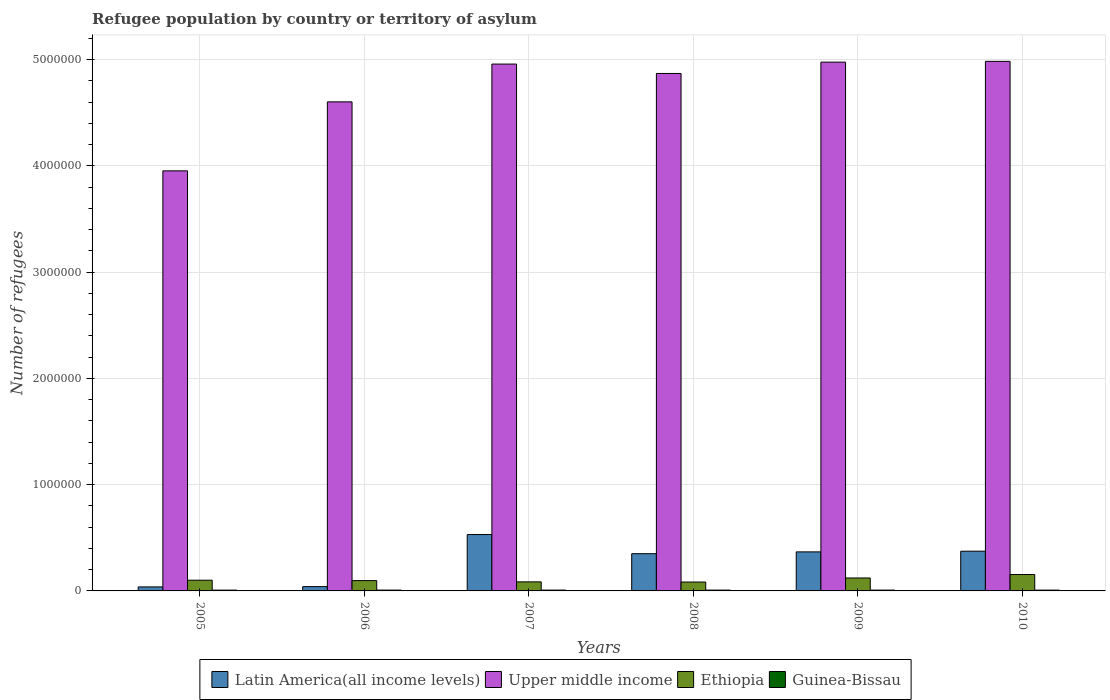How many different coloured bars are there?
Your response must be concise. 4. How many groups of bars are there?
Provide a short and direct response. 6. Are the number of bars per tick equal to the number of legend labels?
Your response must be concise. Yes. How many bars are there on the 3rd tick from the left?
Your answer should be very brief. 4. How many bars are there on the 1st tick from the right?
Keep it short and to the point. 4. What is the label of the 1st group of bars from the left?
Make the answer very short. 2005. In how many cases, is the number of bars for a given year not equal to the number of legend labels?
Keep it short and to the point. 0. What is the number of refugees in Ethiopia in 2010?
Your response must be concise. 1.54e+05. Across all years, what is the maximum number of refugees in Latin America(all income levels)?
Your response must be concise. 5.31e+05. Across all years, what is the minimum number of refugees in Guinea-Bissau?
Ensure brevity in your answer.  7616. In which year was the number of refugees in Ethiopia maximum?
Offer a terse response. 2010. In which year was the number of refugees in Ethiopia minimum?
Offer a very short reply. 2008. What is the total number of refugees in Guinea-Bissau in the graph?
Provide a short and direct response. 4.67e+04. What is the difference between the number of refugees in Latin America(all income levels) in 2008 and that in 2010?
Make the answer very short. -2.36e+04. What is the difference between the number of refugees in Ethiopia in 2009 and the number of refugees in Latin America(all income levels) in 2006?
Keep it short and to the point. 8.13e+04. What is the average number of refugees in Latin America(all income levels) per year?
Make the answer very short. 2.83e+05. In the year 2006, what is the difference between the number of refugees in Upper middle income and number of refugees in Ethiopia?
Ensure brevity in your answer.  4.51e+06. In how many years, is the number of refugees in Guinea-Bissau greater than 4000000?
Your response must be concise. 0. What is the ratio of the number of refugees in Guinea-Bissau in 2008 to that in 2010?
Ensure brevity in your answer.  1.03. Is the difference between the number of refugees in Upper middle income in 2005 and 2006 greater than the difference between the number of refugees in Ethiopia in 2005 and 2006?
Your answer should be very brief. No. What is the difference between the highest and the second highest number of refugees in Ethiopia?
Offer a terse response. 3.24e+04. What is the difference between the highest and the lowest number of refugees in Guinea-Bissau?
Provide a succinct answer. 282. In how many years, is the number of refugees in Ethiopia greater than the average number of refugees in Ethiopia taken over all years?
Offer a very short reply. 2. Is it the case that in every year, the sum of the number of refugees in Latin America(all income levels) and number of refugees in Guinea-Bissau is greater than the sum of number of refugees in Upper middle income and number of refugees in Ethiopia?
Keep it short and to the point. No. What does the 3rd bar from the left in 2006 represents?
Your answer should be compact. Ethiopia. What does the 2nd bar from the right in 2007 represents?
Offer a terse response. Ethiopia. Is it the case that in every year, the sum of the number of refugees in Ethiopia and number of refugees in Upper middle income is greater than the number of refugees in Latin America(all income levels)?
Provide a succinct answer. Yes. Are all the bars in the graph horizontal?
Your response must be concise. No. How many years are there in the graph?
Provide a succinct answer. 6. Are the values on the major ticks of Y-axis written in scientific E-notation?
Your answer should be compact. No. How many legend labels are there?
Make the answer very short. 4. What is the title of the graph?
Provide a succinct answer. Refugee population by country or territory of asylum. What is the label or title of the X-axis?
Offer a very short reply. Years. What is the label or title of the Y-axis?
Offer a very short reply. Number of refugees. What is the Number of refugees of Latin America(all income levels) in 2005?
Offer a terse response. 3.77e+04. What is the Number of refugees in Upper middle income in 2005?
Offer a terse response. 3.95e+06. What is the Number of refugees of Ethiopia in 2005?
Keep it short and to the point. 1.01e+05. What is the Number of refugees of Guinea-Bissau in 2005?
Your response must be concise. 7616. What is the Number of refugees in Latin America(all income levels) in 2006?
Provide a succinct answer. 4.06e+04. What is the Number of refugees in Upper middle income in 2006?
Offer a very short reply. 4.60e+06. What is the Number of refugees in Ethiopia in 2006?
Ensure brevity in your answer.  9.70e+04. What is the Number of refugees of Guinea-Bissau in 2006?
Your answer should be very brief. 7804. What is the Number of refugees in Latin America(all income levels) in 2007?
Make the answer very short. 5.31e+05. What is the Number of refugees of Upper middle income in 2007?
Your response must be concise. 4.96e+06. What is the Number of refugees in Ethiopia in 2007?
Provide a short and direct response. 8.52e+04. What is the Number of refugees of Guinea-Bissau in 2007?
Your answer should be very brief. 7860. What is the Number of refugees in Latin America(all income levels) in 2008?
Your response must be concise. 3.50e+05. What is the Number of refugees of Upper middle income in 2008?
Provide a succinct answer. 4.87e+06. What is the Number of refugees in Ethiopia in 2008?
Keep it short and to the point. 8.36e+04. What is the Number of refugees of Guinea-Bissau in 2008?
Your answer should be compact. 7884. What is the Number of refugees of Latin America(all income levels) in 2009?
Provide a short and direct response. 3.67e+05. What is the Number of refugees of Upper middle income in 2009?
Ensure brevity in your answer.  4.98e+06. What is the Number of refugees of Ethiopia in 2009?
Give a very brief answer. 1.22e+05. What is the Number of refugees of Guinea-Bissau in 2009?
Provide a short and direct response. 7898. What is the Number of refugees of Latin America(all income levels) in 2010?
Give a very brief answer. 3.74e+05. What is the Number of refugees of Upper middle income in 2010?
Your answer should be compact. 4.98e+06. What is the Number of refugees in Ethiopia in 2010?
Offer a very short reply. 1.54e+05. What is the Number of refugees in Guinea-Bissau in 2010?
Your answer should be very brief. 7679. Across all years, what is the maximum Number of refugees of Latin America(all income levels)?
Provide a succinct answer. 5.31e+05. Across all years, what is the maximum Number of refugees in Upper middle income?
Give a very brief answer. 4.98e+06. Across all years, what is the maximum Number of refugees of Ethiopia?
Offer a terse response. 1.54e+05. Across all years, what is the maximum Number of refugees in Guinea-Bissau?
Your answer should be compact. 7898. Across all years, what is the minimum Number of refugees in Latin America(all income levels)?
Ensure brevity in your answer.  3.77e+04. Across all years, what is the minimum Number of refugees in Upper middle income?
Offer a terse response. 3.95e+06. Across all years, what is the minimum Number of refugees in Ethiopia?
Provide a succinct answer. 8.36e+04. Across all years, what is the minimum Number of refugees of Guinea-Bissau?
Make the answer very short. 7616. What is the total Number of refugees of Latin America(all income levels) in the graph?
Ensure brevity in your answer.  1.70e+06. What is the total Number of refugees of Upper middle income in the graph?
Offer a terse response. 2.83e+07. What is the total Number of refugees in Ethiopia in the graph?
Provide a short and direct response. 6.43e+05. What is the total Number of refugees of Guinea-Bissau in the graph?
Your answer should be compact. 4.67e+04. What is the difference between the Number of refugees of Latin America(all income levels) in 2005 and that in 2006?
Keep it short and to the point. -2828. What is the difference between the Number of refugees of Upper middle income in 2005 and that in 2006?
Your response must be concise. -6.49e+05. What is the difference between the Number of refugees in Ethiopia in 2005 and that in 2006?
Your response must be concise. 3837. What is the difference between the Number of refugees in Guinea-Bissau in 2005 and that in 2006?
Your answer should be very brief. -188. What is the difference between the Number of refugees in Latin America(all income levels) in 2005 and that in 2007?
Give a very brief answer. -4.93e+05. What is the difference between the Number of refugees in Upper middle income in 2005 and that in 2007?
Your response must be concise. -1.00e+06. What is the difference between the Number of refugees in Ethiopia in 2005 and that in 2007?
Ensure brevity in your answer.  1.56e+04. What is the difference between the Number of refugees of Guinea-Bissau in 2005 and that in 2007?
Offer a very short reply. -244. What is the difference between the Number of refugees of Latin America(all income levels) in 2005 and that in 2008?
Your response must be concise. -3.13e+05. What is the difference between the Number of refugees of Upper middle income in 2005 and that in 2008?
Keep it short and to the point. -9.16e+05. What is the difference between the Number of refugees in Ethiopia in 2005 and that in 2008?
Offer a very short reply. 1.72e+04. What is the difference between the Number of refugees of Guinea-Bissau in 2005 and that in 2008?
Offer a very short reply. -268. What is the difference between the Number of refugees in Latin America(all income levels) in 2005 and that in 2009?
Offer a terse response. -3.30e+05. What is the difference between the Number of refugees of Upper middle income in 2005 and that in 2009?
Your answer should be very brief. -1.02e+06. What is the difference between the Number of refugees of Ethiopia in 2005 and that in 2009?
Keep it short and to the point. -2.11e+04. What is the difference between the Number of refugees in Guinea-Bissau in 2005 and that in 2009?
Your answer should be very brief. -282. What is the difference between the Number of refugees in Latin America(all income levels) in 2005 and that in 2010?
Your answer should be very brief. -3.36e+05. What is the difference between the Number of refugees of Upper middle income in 2005 and that in 2010?
Provide a succinct answer. -1.03e+06. What is the difference between the Number of refugees in Ethiopia in 2005 and that in 2010?
Provide a short and direct response. -5.35e+04. What is the difference between the Number of refugees in Guinea-Bissau in 2005 and that in 2010?
Provide a short and direct response. -63. What is the difference between the Number of refugees of Latin America(all income levels) in 2006 and that in 2007?
Ensure brevity in your answer.  -4.90e+05. What is the difference between the Number of refugees in Upper middle income in 2006 and that in 2007?
Provide a succinct answer. -3.55e+05. What is the difference between the Number of refugees of Ethiopia in 2006 and that in 2007?
Provide a succinct answer. 1.18e+04. What is the difference between the Number of refugees in Guinea-Bissau in 2006 and that in 2007?
Ensure brevity in your answer.  -56. What is the difference between the Number of refugees in Latin America(all income levels) in 2006 and that in 2008?
Provide a succinct answer. -3.10e+05. What is the difference between the Number of refugees of Upper middle income in 2006 and that in 2008?
Your answer should be compact. -2.67e+05. What is the difference between the Number of refugees of Ethiopia in 2006 and that in 2008?
Your response must be concise. 1.34e+04. What is the difference between the Number of refugees of Guinea-Bissau in 2006 and that in 2008?
Make the answer very short. -80. What is the difference between the Number of refugees in Latin America(all income levels) in 2006 and that in 2009?
Provide a succinct answer. -3.27e+05. What is the difference between the Number of refugees in Upper middle income in 2006 and that in 2009?
Provide a succinct answer. -3.74e+05. What is the difference between the Number of refugees in Ethiopia in 2006 and that in 2009?
Offer a terse response. -2.49e+04. What is the difference between the Number of refugees in Guinea-Bissau in 2006 and that in 2009?
Keep it short and to the point. -94. What is the difference between the Number of refugees in Latin America(all income levels) in 2006 and that in 2010?
Keep it short and to the point. -3.33e+05. What is the difference between the Number of refugees in Upper middle income in 2006 and that in 2010?
Keep it short and to the point. -3.81e+05. What is the difference between the Number of refugees in Ethiopia in 2006 and that in 2010?
Your answer should be compact. -5.73e+04. What is the difference between the Number of refugees in Guinea-Bissau in 2006 and that in 2010?
Make the answer very short. 125. What is the difference between the Number of refugees of Latin America(all income levels) in 2007 and that in 2008?
Make the answer very short. 1.80e+05. What is the difference between the Number of refugees of Upper middle income in 2007 and that in 2008?
Keep it short and to the point. 8.84e+04. What is the difference between the Number of refugees of Ethiopia in 2007 and that in 2008?
Provide a succinct answer. 1600. What is the difference between the Number of refugees in Latin America(all income levels) in 2007 and that in 2009?
Your answer should be very brief. 1.63e+05. What is the difference between the Number of refugees in Upper middle income in 2007 and that in 2009?
Your response must be concise. -1.83e+04. What is the difference between the Number of refugees of Ethiopia in 2007 and that in 2009?
Provide a short and direct response. -3.67e+04. What is the difference between the Number of refugees in Guinea-Bissau in 2007 and that in 2009?
Give a very brief answer. -38. What is the difference between the Number of refugees in Latin America(all income levels) in 2007 and that in 2010?
Offer a terse response. 1.57e+05. What is the difference between the Number of refugees in Upper middle income in 2007 and that in 2010?
Make the answer very short. -2.56e+04. What is the difference between the Number of refugees of Ethiopia in 2007 and that in 2010?
Make the answer very short. -6.91e+04. What is the difference between the Number of refugees in Guinea-Bissau in 2007 and that in 2010?
Keep it short and to the point. 181. What is the difference between the Number of refugees of Latin America(all income levels) in 2008 and that in 2009?
Your response must be concise. -1.72e+04. What is the difference between the Number of refugees in Upper middle income in 2008 and that in 2009?
Offer a very short reply. -1.07e+05. What is the difference between the Number of refugees of Ethiopia in 2008 and that in 2009?
Provide a short and direct response. -3.83e+04. What is the difference between the Number of refugees in Guinea-Bissau in 2008 and that in 2009?
Ensure brevity in your answer.  -14. What is the difference between the Number of refugees in Latin America(all income levels) in 2008 and that in 2010?
Offer a very short reply. -2.36e+04. What is the difference between the Number of refugees of Upper middle income in 2008 and that in 2010?
Your response must be concise. -1.14e+05. What is the difference between the Number of refugees in Ethiopia in 2008 and that in 2010?
Give a very brief answer. -7.07e+04. What is the difference between the Number of refugees of Guinea-Bissau in 2008 and that in 2010?
Offer a terse response. 205. What is the difference between the Number of refugees of Latin America(all income levels) in 2009 and that in 2010?
Provide a succinct answer. -6428. What is the difference between the Number of refugees in Upper middle income in 2009 and that in 2010?
Offer a terse response. -7314. What is the difference between the Number of refugees in Ethiopia in 2009 and that in 2010?
Your response must be concise. -3.24e+04. What is the difference between the Number of refugees of Guinea-Bissau in 2009 and that in 2010?
Provide a short and direct response. 219. What is the difference between the Number of refugees of Latin America(all income levels) in 2005 and the Number of refugees of Upper middle income in 2006?
Provide a succinct answer. -4.56e+06. What is the difference between the Number of refugees in Latin America(all income levels) in 2005 and the Number of refugees in Ethiopia in 2006?
Give a very brief answer. -5.92e+04. What is the difference between the Number of refugees in Latin America(all income levels) in 2005 and the Number of refugees in Guinea-Bissau in 2006?
Give a very brief answer. 2.99e+04. What is the difference between the Number of refugees of Upper middle income in 2005 and the Number of refugees of Ethiopia in 2006?
Make the answer very short. 3.86e+06. What is the difference between the Number of refugees of Upper middle income in 2005 and the Number of refugees of Guinea-Bissau in 2006?
Ensure brevity in your answer.  3.95e+06. What is the difference between the Number of refugees in Ethiopia in 2005 and the Number of refugees in Guinea-Bissau in 2006?
Provide a succinct answer. 9.30e+04. What is the difference between the Number of refugees in Latin America(all income levels) in 2005 and the Number of refugees in Upper middle income in 2007?
Offer a very short reply. -4.92e+06. What is the difference between the Number of refugees in Latin America(all income levels) in 2005 and the Number of refugees in Ethiopia in 2007?
Your response must be concise. -4.74e+04. What is the difference between the Number of refugees of Latin America(all income levels) in 2005 and the Number of refugees of Guinea-Bissau in 2007?
Your answer should be compact. 2.99e+04. What is the difference between the Number of refugees of Upper middle income in 2005 and the Number of refugees of Ethiopia in 2007?
Offer a very short reply. 3.87e+06. What is the difference between the Number of refugees in Upper middle income in 2005 and the Number of refugees in Guinea-Bissau in 2007?
Provide a succinct answer. 3.95e+06. What is the difference between the Number of refugees in Ethiopia in 2005 and the Number of refugees in Guinea-Bissau in 2007?
Make the answer very short. 9.30e+04. What is the difference between the Number of refugees in Latin America(all income levels) in 2005 and the Number of refugees in Upper middle income in 2008?
Ensure brevity in your answer.  -4.83e+06. What is the difference between the Number of refugees of Latin America(all income levels) in 2005 and the Number of refugees of Ethiopia in 2008?
Offer a terse response. -4.58e+04. What is the difference between the Number of refugees in Latin America(all income levels) in 2005 and the Number of refugees in Guinea-Bissau in 2008?
Provide a succinct answer. 2.99e+04. What is the difference between the Number of refugees in Upper middle income in 2005 and the Number of refugees in Ethiopia in 2008?
Provide a succinct answer. 3.87e+06. What is the difference between the Number of refugees of Upper middle income in 2005 and the Number of refugees of Guinea-Bissau in 2008?
Your response must be concise. 3.95e+06. What is the difference between the Number of refugees in Ethiopia in 2005 and the Number of refugees in Guinea-Bissau in 2008?
Give a very brief answer. 9.29e+04. What is the difference between the Number of refugees in Latin America(all income levels) in 2005 and the Number of refugees in Upper middle income in 2009?
Provide a succinct answer. -4.94e+06. What is the difference between the Number of refugees of Latin America(all income levels) in 2005 and the Number of refugees of Ethiopia in 2009?
Provide a short and direct response. -8.41e+04. What is the difference between the Number of refugees in Latin America(all income levels) in 2005 and the Number of refugees in Guinea-Bissau in 2009?
Provide a short and direct response. 2.99e+04. What is the difference between the Number of refugees in Upper middle income in 2005 and the Number of refugees in Ethiopia in 2009?
Provide a short and direct response. 3.83e+06. What is the difference between the Number of refugees of Upper middle income in 2005 and the Number of refugees of Guinea-Bissau in 2009?
Offer a very short reply. 3.95e+06. What is the difference between the Number of refugees in Ethiopia in 2005 and the Number of refugees in Guinea-Bissau in 2009?
Provide a succinct answer. 9.29e+04. What is the difference between the Number of refugees of Latin America(all income levels) in 2005 and the Number of refugees of Upper middle income in 2010?
Give a very brief answer. -4.95e+06. What is the difference between the Number of refugees of Latin America(all income levels) in 2005 and the Number of refugees of Ethiopia in 2010?
Offer a terse response. -1.17e+05. What is the difference between the Number of refugees of Latin America(all income levels) in 2005 and the Number of refugees of Guinea-Bissau in 2010?
Provide a short and direct response. 3.01e+04. What is the difference between the Number of refugees of Upper middle income in 2005 and the Number of refugees of Ethiopia in 2010?
Keep it short and to the point. 3.80e+06. What is the difference between the Number of refugees of Upper middle income in 2005 and the Number of refugees of Guinea-Bissau in 2010?
Provide a short and direct response. 3.95e+06. What is the difference between the Number of refugees in Ethiopia in 2005 and the Number of refugees in Guinea-Bissau in 2010?
Keep it short and to the point. 9.31e+04. What is the difference between the Number of refugees of Latin America(all income levels) in 2006 and the Number of refugees of Upper middle income in 2007?
Give a very brief answer. -4.92e+06. What is the difference between the Number of refugees of Latin America(all income levels) in 2006 and the Number of refugees of Ethiopia in 2007?
Offer a very short reply. -4.46e+04. What is the difference between the Number of refugees of Latin America(all income levels) in 2006 and the Number of refugees of Guinea-Bissau in 2007?
Your answer should be very brief. 3.27e+04. What is the difference between the Number of refugees in Upper middle income in 2006 and the Number of refugees in Ethiopia in 2007?
Provide a short and direct response. 4.52e+06. What is the difference between the Number of refugees in Upper middle income in 2006 and the Number of refugees in Guinea-Bissau in 2007?
Your response must be concise. 4.59e+06. What is the difference between the Number of refugees of Ethiopia in 2006 and the Number of refugees of Guinea-Bissau in 2007?
Your answer should be compact. 8.91e+04. What is the difference between the Number of refugees in Latin America(all income levels) in 2006 and the Number of refugees in Upper middle income in 2008?
Offer a very short reply. -4.83e+06. What is the difference between the Number of refugees of Latin America(all income levels) in 2006 and the Number of refugees of Ethiopia in 2008?
Provide a succinct answer. -4.30e+04. What is the difference between the Number of refugees of Latin America(all income levels) in 2006 and the Number of refugees of Guinea-Bissau in 2008?
Provide a succinct answer. 3.27e+04. What is the difference between the Number of refugees of Upper middle income in 2006 and the Number of refugees of Ethiopia in 2008?
Give a very brief answer. 4.52e+06. What is the difference between the Number of refugees in Upper middle income in 2006 and the Number of refugees in Guinea-Bissau in 2008?
Your answer should be compact. 4.59e+06. What is the difference between the Number of refugees of Ethiopia in 2006 and the Number of refugees of Guinea-Bissau in 2008?
Offer a terse response. 8.91e+04. What is the difference between the Number of refugees of Latin America(all income levels) in 2006 and the Number of refugees of Upper middle income in 2009?
Keep it short and to the point. -4.94e+06. What is the difference between the Number of refugees in Latin America(all income levels) in 2006 and the Number of refugees in Ethiopia in 2009?
Offer a very short reply. -8.13e+04. What is the difference between the Number of refugees of Latin America(all income levels) in 2006 and the Number of refugees of Guinea-Bissau in 2009?
Provide a short and direct response. 3.27e+04. What is the difference between the Number of refugees in Upper middle income in 2006 and the Number of refugees in Ethiopia in 2009?
Offer a terse response. 4.48e+06. What is the difference between the Number of refugees in Upper middle income in 2006 and the Number of refugees in Guinea-Bissau in 2009?
Offer a very short reply. 4.59e+06. What is the difference between the Number of refugees of Ethiopia in 2006 and the Number of refugees of Guinea-Bissau in 2009?
Provide a short and direct response. 8.91e+04. What is the difference between the Number of refugees of Latin America(all income levels) in 2006 and the Number of refugees of Upper middle income in 2010?
Offer a very short reply. -4.94e+06. What is the difference between the Number of refugees of Latin America(all income levels) in 2006 and the Number of refugees of Ethiopia in 2010?
Your answer should be compact. -1.14e+05. What is the difference between the Number of refugees in Latin America(all income levels) in 2006 and the Number of refugees in Guinea-Bissau in 2010?
Give a very brief answer. 3.29e+04. What is the difference between the Number of refugees of Upper middle income in 2006 and the Number of refugees of Ethiopia in 2010?
Make the answer very short. 4.45e+06. What is the difference between the Number of refugees of Upper middle income in 2006 and the Number of refugees of Guinea-Bissau in 2010?
Give a very brief answer. 4.59e+06. What is the difference between the Number of refugees of Ethiopia in 2006 and the Number of refugees of Guinea-Bissau in 2010?
Provide a succinct answer. 8.93e+04. What is the difference between the Number of refugees of Latin America(all income levels) in 2007 and the Number of refugees of Upper middle income in 2008?
Give a very brief answer. -4.34e+06. What is the difference between the Number of refugees in Latin America(all income levels) in 2007 and the Number of refugees in Ethiopia in 2008?
Give a very brief answer. 4.47e+05. What is the difference between the Number of refugees in Latin America(all income levels) in 2007 and the Number of refugees in Guinea-Bissau in 2008?
Provide a succinct answer. 5.23e+05. What is the difference between the Number of refugees in Upper middle income in 2007 and the Number of refugees in Ethiopia in 2008?
Your answer should be very brief. 4.87e+06. What is the difference between the Number of refugees in Upper middle income in 2007 and the Number of refugees in Guinea-Bissau in 2008?
Your answer should be compact. 4.95e+06. What is the difference between the Number of refugees in Ethiopia in 2007 and the Number of refugees in Guinea-Bissau in 2008?
Offer a terse response. 7.73e+04. What is the difference between the Number of refugees in Latin America(all income levels) in 2007 and the Number of refugees in Upper middle income in 2009?
Offer a terse response. -4.45e+06. What is the difference between the Number of refugees in Latin America(all income levels) in 2007 and the Number of refugees in Ethiopia in 2009?
Give a very brief answer. 4.09e+05. What is the difference between the Number of refugees of Latin America(all income levels) in 2007 and the Number of refugees of Guinea-Bissau in 2009?
Provide a short and direct response. 5.23e+05. What is the difference between the Number of refugees in Upper middle income in 2007 and the Number of refugees in Ethiopia in 2009?
Offer a terse response. 4.84e+06. What is the difference between the Number of refugees of Upper middle income in 2007 and the Number of refugees of Guinea-Bissau in 2009?
Your answer should be very brief. 4.95e+06. What is the difference between the Number of refugees in Ethiopia in 2007 and the Number of refugees in Guinea-Bissau in 2009?
Make the answer very short. 7.73e+04. What is the difference between the Number of refugees in Latin America(all income levels) in 2007 and the Number of refugees in Upper middle income in 2010?
Keep it short and to the point. -4.45e+06. What is the difference between the Number of refugees in Latin America(all income levels) in 2007 and the Number of refugees in Ethiopia in 2010?
Keep it short and to the point. 3.76e+05. What is the difference between the Number of refugees of Latin America(all income levels) in 2007 and the Number of refugees of Guinea-Bissau in 2010?
Make the answer very short. 5.23e+05. What is the difference between the Number of refugees of Upper middle income in 2007 and the Number of refugees of Ethiopia in 2010?
Ensure brevity in your answer.  4.80e+06. What is the difference between the Number of refugees of Upper middle income in 2007 and the Number of refugees of Guinea-Bissau in 2010?
Offer a terse response. 4.95e+06. What is the difference between the Number of refugees of Ethiopia in 2007 and the Number of refugees of Guinea-Bissau in 2010?
Keep it short and to the point. 7.75e+04. What is the difference between the Number of refugees in Latin America(all income levels) in 2008 and the Number of refugees in Upper middle income in 2009?
Offer a very short reply. -4.63e+06. What is the difference between the Number of refugees of Latin America(all income levels) in 2008 and the Number of refugees of Ethiopia in 2009?
Provide a succinct answer. 2.28e+05. What is the difference between the Number of refugees in Latin America(all income levels) in 2008 and the Number of refugees in Guinea-Bissau in 2009?
Provide a short and direct response. 3.42e+05. What is the difference between the Number of refugees in Upper middle income in 2008 and the Number of refugees in Ethiopia in 2009?
Provide a succinct answer. 4.75e+06. What is the difference between the Number of refugees in Upper middle income in 2008 and the Number of refugees in Guinea-Bissau in 2009?
Your answer should be very brief. 4.86e+06. What is the difference between the Number of refugees in Ethiopia in 2008 and the Number of refugees in Guinea-Bissau in 2009?
Provide a short and direct response. 7.57e+04. What is the difference between the Number of refugees of Latin America(all income levels) in 2008 and the Number of refugees of Upper middle income in 2010?
Your answer should be compact. -4.63e+06. What is the difference between the Number of refugees of Latin America(all income levels) in 2008 and the Number of refugees of Ethiopia in 2010?
Ensure brevity in your answer.  1.96e+05. What is the difference between the Number of refugees in Latin America(all income levels) in 2008 and the Number of refugees in Guinea-Bissau in 2010?
Make the answer very short. 3.43e+05. What is the difference between the Number of refugees of Upper middle income in 2008 and the Number of refugees of Ethiopia in 2010?
Provide a succinct answer. 4.72e+06. What is the difference between the Number of refugees in Upper middle income in 2008 and the Number of refugees in Guinea-Bissau in 2010?
Your answer should be compact. 4.86e+06. What is the difference between the Number of refugees in Ethiopia in 2008 and the Number of refugees in Guinea-Bissau in 2010?
Your answer should be compact. 7.59e+04. What is the difference between the Number of refugees of Latin America(all income levels) in 2009 and the Number of refugees of Upper middle income in 2010?
Offer a very short reply. -4.62e+06. What is the difference between the Number of refugees of Latin America(all income levels) in 2009 and the Number of refugees of Ethiopia in 2010?
Make the answer very short. 2.13e+05. What is the difference between the Number of refugees of Latin America(all income levels) in 2009 and the Number of refugees of Guinea-Bissau in 2010?
Your answer should be compact. 3.60e+05. What is the difference between the Number of refugees of Upper middle income in 2009 and the Number of refugees of Ethiopia in 2010?
Provide a short and direct response. 4.82e+06. What is the difference between the Number of refugees of Upper middle income in 2009 and the Number of refugees of Guinea-Bissau in 2010?
Provide a succinct answer. 4.97e+06. What is the difference between the Number of refugees in Ethiopia in 2009 and the Number of refugees in Guinea-Bissau in 2010?
Keep it short and to the point. 1.14e+05. What is the average Number of refugees of Latin America(all income levels) per year?
Ensure brevity in your answer.  2.83e+05. What is the average Number of refugees of Upper middle income per year?
Make the answer very short. 4.72e+06. What is the average Number of refugees of Ethiopia per year?
Your response must be concise. 1.07e+05. What is the average Number of refugees in Guinea-Bissau per year?
Keep it short and to the point. 7790.17. In the year 2005, what is the difference between the Number of refugees in Latin America(all income levels) and Number of refugees in Upper middle income?
Provide a succinct answer. -3.92e+06. In the year 2005, what is the difference between the Number of refugees of Latin America(all income levels) and Number of refugees of Ethiopia?
Give a very brief answer. -6.31e+04. In the year 2005, what is the difference between the Number of refugees of Latin America(all income levels) and Number of refugees of Guinea-Bissau?
Your response must be concise. 3.01e+04. In the year 2005, what is the difference between the Number of refugees of Upper middle income and Number of refugees of Ethiopia?
Your answer should be very brief. 3.85e+06. In the year 2005, what is the difference between the Number of refugees of Upper middle income and Number of refugees of Guinea-Bissau?
Provide a succinct answer. 3.95e+06. In the year 2005, what is the difference between the Number of refugees in Ethiopia and Number of refugees in Guinea-Bissau?
Offer a terse response. 9.32e+04. In the year 2006, what is the difference between the Number of refugees of Latin America(all income levels) and Number of refugees of Upper middle income?
Keep it short and to the point. -4.56e+06. In the year 2006, what is the difference between the Number of refugees of Latin America(all income levels) and Number of refugees of Ethiopia?
Your response must be concise. -5.64e+04. In the year 2006, what is the difference between the Number of refugees of Latin America(all income levels) and Number of refugees of Guinea-Bissau?
Offer a very short reply. 3.28e+04. In the year 2006, what is the difference between the Number of refugees in Upper middle income and Number of refugees in Ethiopia?
Offer a terse response. 4.51e+06. In the year 2006, what is the difference between the Number of refugees of Upper middle income and Number of refugees of Guinea-Bissau?
Your answer should be compact. 4.59e+06. In the year 2006, what is the difference between the Number of refugees in Ethiopia and Number of refugees in Guinea-Bissau?
Your response must be concise. 8.92e+04. In the year 2007, what is the difference between the Number of refugees in Latin America(all income levels) and Number of refugees in Upper middle income?
Offer a very short reply. -4.43e+06. In the year 2007, what is the difference between the Number of refugees of Latin America(all income levels) and Number of refugees of Ethiopia?
Offer a terse response. 4.45e+05. In the year 2007, what is the difference between the Number of refugees in Latin America(all income levels) and Number of refugees in Guinea-Bissau?
Offer a terse response. 5.23e+05. In the year 2007, what is the difference between the Number of refugees of Upper middle income and Number of refugees of Ethiopia?
Make the answer very short. 4.87e+06. In the year 2007, what is the difference between the Number of refugees in Upper middle income and Number of refugees in Guinea-Bissau?
Provide a short and direct response. 4.95e+06. In the year 2007, what is the difference between the Number of refugees in Ethiopia and Number of refugees in Guinea-Bissau?
Provide a short and direct response. 7.73e+04. In the year 2008, what is the difference between the Number of refugees of Latin America(all income levels) and Number of refugees of Upper middle income?
Your response must be concise. -4.52e+06. In the year 2008, what is the difference between the Number of refugees in Latin America(all income levels) and Number of refugees in Ethiopia?
Provide a succinct answer. 2.67e+05. In the year 2008, what is the difference between the Number of refugees in Latin America(all income levels) and Number of refugees in Guinea-Bissau?
Keep it short and to the point. 3.42e+05. In the year 2008, what is the difference between the Number of refugees in Upper middle income and Number of refugees in Ethiopia?
Your answer should be very brief. 4.79e+06. In the year 2008, what is the difference between the Number of refugees of Upper middle income and Number of refugees of Guinea-Bissau?
Your response must be concise. 4.86e+06. In the year 2008, what is the difference between the Number of refugees in Ethiopia and Number of refugees in Guinea-Bissau?
Provide a succinct answer. 7.57e+04. In the year 2009, what is the difference between the Number of refugees in Latin America(all income levels) and Number of refugees in Upper middle income?
Ensure brevity in your answer.  -4.61e+06. In the year 2009, what is the difference between the Number of refugees in Latin America(all income levels) and Number of refugees in Ethiopia?
Provide a short and direct response. 2.46e+05. In the year 2009, what is the difference between the Number of refugees of Latin America(all income levels) and Number of refugees of Guinea-Bissau?
Provide a succinct answer. 3.60e+05. In the year 2009, what is the difference between the Number of refugees of Upper middle income and Number of refugees of Ethiopia?
Your response must be concise. 4.85e+06. In the year 2009, what is the difference between the Number of refugees in Upper middle income and Number of refugees in Guinea-Bissau?
Give a very brief answer. 4.97e+06. In the year 2009, what is the difference between the Number of refugees in Ethiopia and Number of refugees in Guinea-Bissau?
Give a very brief answer. 1.14e+05. In the year 2010, what is the difference between the Number of refugees of Latin America(all income levels) and Number of refugees of Upper middle income?
Give a very brief answer. -4.61e+06. In the year 2010, what is the difference between the Number of refugees in Latin America(all income levels) and Number of refugees in Ethiopia?
Offer a very short reply. 2.20e+05. In the year 2010, what is the difference between the Number of refugees of Latin America(all income levels) and Number of refugees of Guinea-Bissau?
Your answer should be compact. 3.66e+05. In the year 2010, what is the difference between the Number of refugees in Upper middle income and Number of refugees in Ethiopia?
Make the answer very short. 4.83e+06. In the year 2010, what is the difference between the Number of refugees in Upper middle income and Number of refugees in Guinea-Bissau?
Keep it short and to the point. 4.98e+06. In the year 2010, what is the difference between the Number of refugees in Ethiopia and Number of refugees in Guinea-Bissau?
Your response must be concise. 1.47e+05. What is the ratio of the Number of refugees in Latin America(all income levels) in 2005 to that in 2006?
Your answer should be compact. 0.93. What is the ratio of the Number of refugees of Upper middle income in 2005 to that in 2006?
Offer a very short reply. 0.86. What is the ratio of the Number of refugees of Ethiopia in 2005 to that in 2006?
Offer a terse response. 1.04. What is the ratio of the Number of refugees in Guinea-Bissau in 2005 to that in 2006?
Provide a short and direct response. 0.98. What is the ratio of the Number of refugees of Latin America(all income levels) in 2005 to that in 2007?
Your answer should be very brief. 0.07. What is the ratio of the Number of refugees of Upper middle income in 2005 to that in 2007?
Your answer should be compact. 0.8. What is the ratio of the Number of refugees in Ethiopia in 2005 to that in 2007?
Provide a short and direct response. 1.18. What is the ratio of the Number of refugees of Guinea-Bissau in 2005 to that in 2007?
Offer a very short reply. 0.97. What is the ratio of the Number of refugees in Latin America(all income levels) in 2005 to that in 2008?
Keep it short and to the point. 0.11. What is the ratio of the Number of refugees of Upper middle income in 2005 to that in 2008?
Provide a short and direct response. 0.81. What is the ratio of the Number of refugees in Ethiopia in 2005 to that in 2008?
Keep it short and to the point. 1.21. What is the ratio of the Number of refugees of Latin America(all income levels) in 2005 to that in 2009?
Offer a terse response. 0.1. What is the ratio of the Number of refugees in Upper middle income in 2005 to that in 2009?
Ensure brevity in your answer.  0.79. What is the ratio of the Number of refugees of Ethiopia in 2005 to that in 2009?
Keep it short and to the point. 0.83. What is the ratio of the Number of refugees of Latin America(all income levels) in 2005 to that in 2010?
Your response must be concise. 0.1. What is the ratio of the Number of refugees in Upper middle income in 2005 to that in 2010?
Provide a succinct answer. 0.79. What is the ratio of the Number of refugees in Ethiopia in 2005 to that in 2010?
Make the answer very short. 0.65. What is the ratio of the Number of refugees of Latin America(all income levels) in 2006 to that in 2007?
Provide a succinct answer. 0.08. What is the ratio of the Number of refugees in Upper middle income in 2006 to that in 2007?
Keep it short and to the point. 0.93. What is the ratio of the Number of refugees in Ethiopia in 2006 to that in 2007?
Your response must be concise. 1.14. What is the ratio of the Number of refugees of Latin America(all income levels) in 2006 to that in 2008?
Offer a very short reply. 0.12. What is the ratio of the Number of refugees of Upper middle income in 2006 to that in 2008?
Provide a succinct answer. 0.95. What is the ratio of the Number of refugees of Ethiopia in 2006 to that in 2008?
Offer a terse response. 1.16. What is the ratio of the Number of refugees of Guinea-Bissau in 2006 to that in 2008?
Your answer should be compact. 0.99. What is the ratio of the Number of refugees in Latin America(all income levels) in 2006 to that in 2009?
Your response must be concise. 0.11. What is the ratio of the Number of refugees of Upper middle income in 2006 to that in 2009?
Offer a terse response. 0.92. What is the ratio of the Number of refugees in Ethiopia in 2006 to that in 2009?
Offer a very short reply. 0.8. What is the ratio of the Number of refugees in Latin America(all income levels) in 2006 to that in 2010?
Your response must be concise. 0.11. What is the ratio of the Number of refugees in Upper middle income in 2006 to that in 2010?
Provide a short and direct response. 0.92. What is the ratio of the Number of refugees in Ethiopia in 2006 to that in 2010?
Make the answer very short. 0.63. What is the ratio of the Number of refugees in Guinea-Bissau in 2006 to that in 2010?
Provide a succinct answer. 1.02. What is the ratio of the Number of refugees in Latin America(all income levels) in 2007 to that in 2008?
Ensure brevity in your answer.  1.51. What is the ratio of the Number of refugees of Upper middle income in 2007 to that in 2008?
Provide a succinct answer. 1.02. What is the ratio of the Number of refugees of Ethiopia in 2007 to that in 2008?
Make the answer very short. 1.02. What is the ratio of the Number of refugees in Latin America(all income levels) in 2007 to that in 2009?
Your response must be concise. 1.44. What is the ratio of the Number of refugees of Ethiopia in 2007 to that in 2009?
Give a very brief answer. 0.7. What is the ratio of the Number of refugees of Guinea-Bissau in 2007 to that in 2009?
Your response must be concise. 1. What is the ratio of the Number of refugees in Latin America(all income levels) in 2007 to that in 2010?
Provide a succinct answer. 1.42. What is the ratio of the Number of refugees in Upper middle income in 2007 to that in 2010?
Provide a succinct answer. 0.99. What is the ratio of the Number of refugees in Ethiopia in 2007 to that in 2010?
Offer a very short reply. 0.55. What is the ratio of the Number of refugees in Guinea-Bissau in 2007 to that in 2010?
Provide a short and direct response. 1.02. What is the ratio of the Number of refugees in Latin America(all income levels) in 2008 to that in 2009?
Make the answer very short. 0.95. What is the ratio of the Number of refugees of Upper middle income in 2008 to that in 2009?
Provide a short and direct response. 0.98. What is the ratio of the Number of refugees in Ethiopia in 2008 to that in 2009?
Offer a very short reply. 0.69. What is the ratio of the Number of refugees of Guinea-Bissau in 2008 to that in 2009?
Make the answer very short. 1. What is the ratio of the Number of refugees in Latin America(all income levels) in 2008 to that in 2010?
Offer a terse response. 0.94. What is the ratio of the Number of refugees in Upper middle income in 2008 to that in 2010?
Offer a terse response. 0.98. What is the ratio of the Number of refugees of Ethiopia in 2008 to that in 2010?
Your response must be concise. 0.54. What is the ratio of the Number of refugees of Guinea-Bissau in 2008 to that in 2010?
Give a very brief answer. 1.03. What is the ratio of the Number of refugees in Latin America(all income levels) in 2009 to that in 2010?
Provide a succinct answer. 0.98. What is the ratio of the Number of refugees of Upper middle income in 2009 to that in 2010?
Offer a very short reply. 1. What is the ratio of the Number of refugees in Ethiopia in 2009 to that in 2010?
Keep it short and to the point. 0.79. What is the ratio of the Number of refugees in Guinea-Bissau in 2009 to that in 2010?
Keep it short and to the point. 1.03. What is the difference between the highest and the second highest Number of refugees in Latin America(all income levels)?
Offer a very short reply. 1.57e+05. What is the difference between the highest and the second highest Number of refugees of Upper middle income?
Make the answer very short. 7314. What is the difference between the highest and the second highest Number of refugees in Ethiopia?
Make the answer very short. 3.24e+04. What is the difference between the highest and the lowest Number of refugees of Latin America(all income levels)?
Ensure brevity in your answer.  4.93e+05. What is the difference between the highest and the lowest Number of refugees in Upper middle income?
Offer a terse response. 1.03e+06. What is the difference between the highest and the lowest Number of refugees of Ethiopia?
Make the answer very short. 7.07e+04. What is the difference between the highest and the lowest Number of refugees of Guinea-Bissau?
Offer a very short reply. 282. 